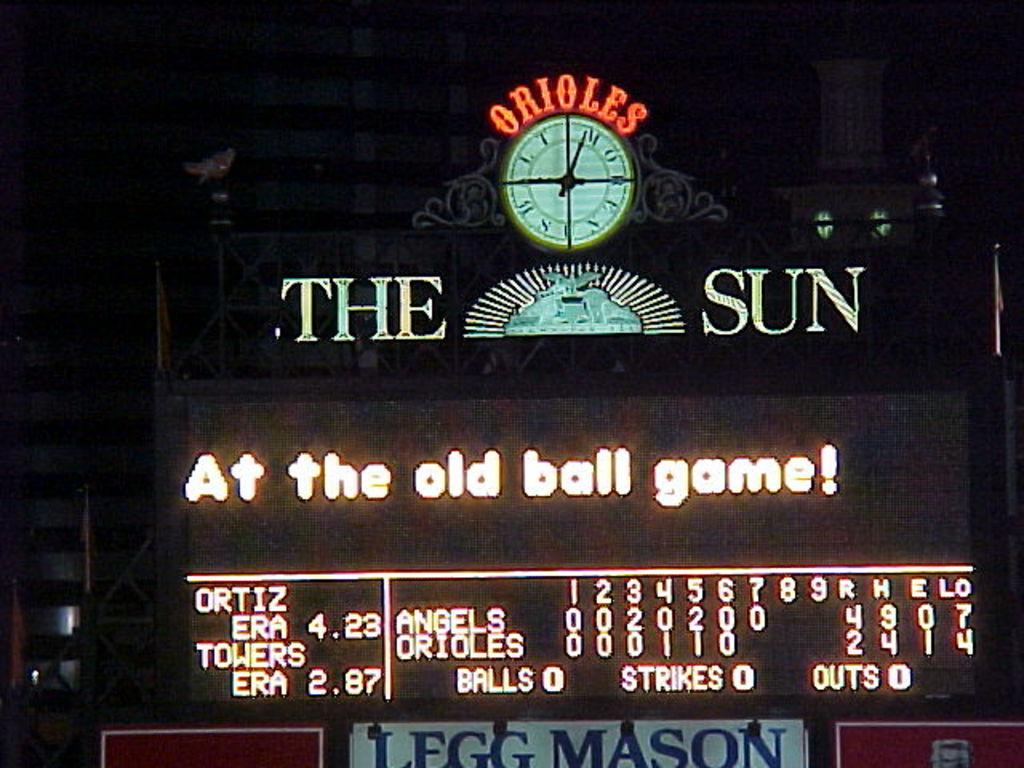Provide a one-sentence caption for the provided image. The scoreboard at the Orioles stadium shows the Angels leading the Orioles in runs. 